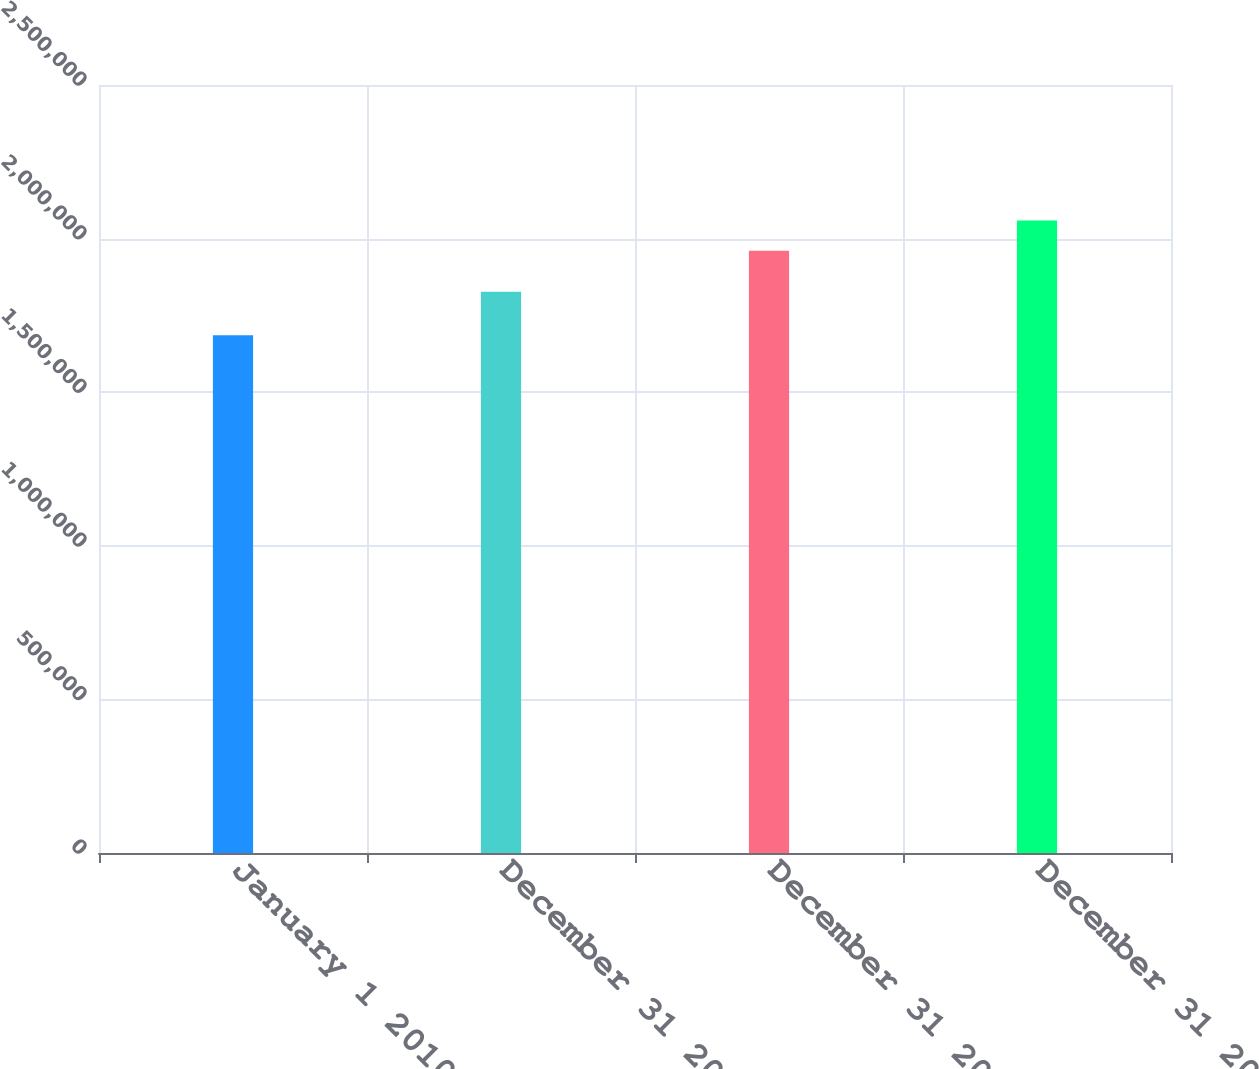<chart> <loc_0><loc_0><loc_500><loc_500><bar_chart><fcel>January 1 2010<fcel>December 31 2010<fcel>December 31 2011<fcel>December 31 2012<nl><fcel>1.68571e+06<fcel>1.8268e+06<fcel>1.96037e+06<fcel>2.05902e+06<nl></chart> 